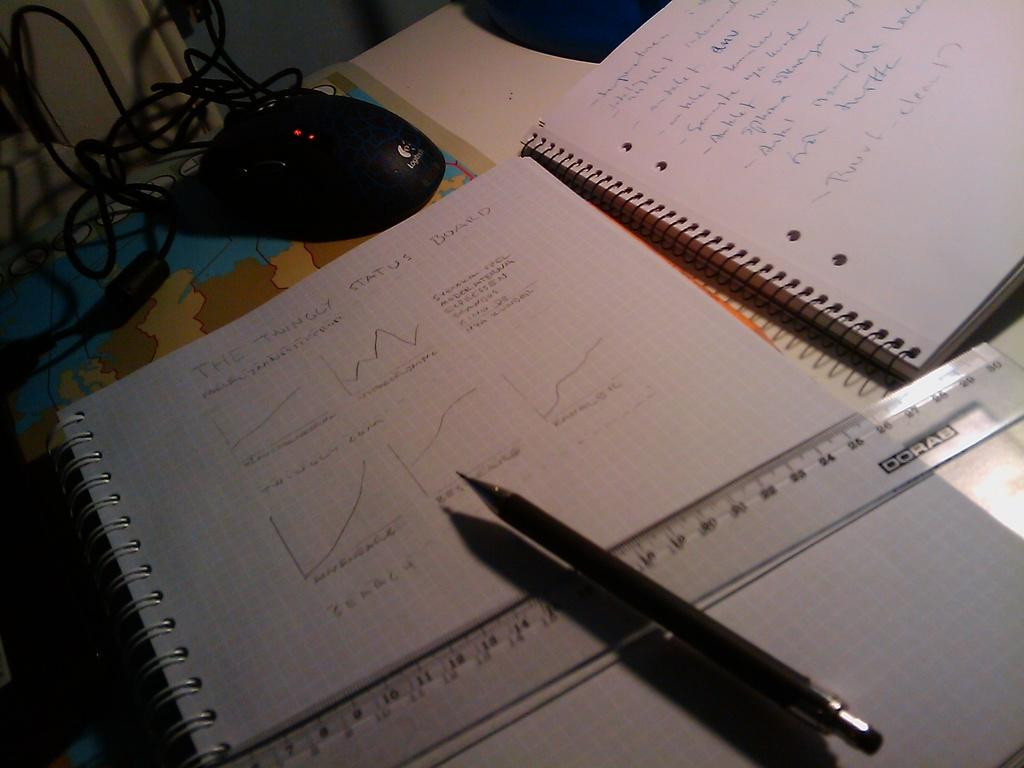Provide a one-sentence caption for the provided image. Two notebooks with writing about The Twingly Status Board on a desk with a pen and ruler. 